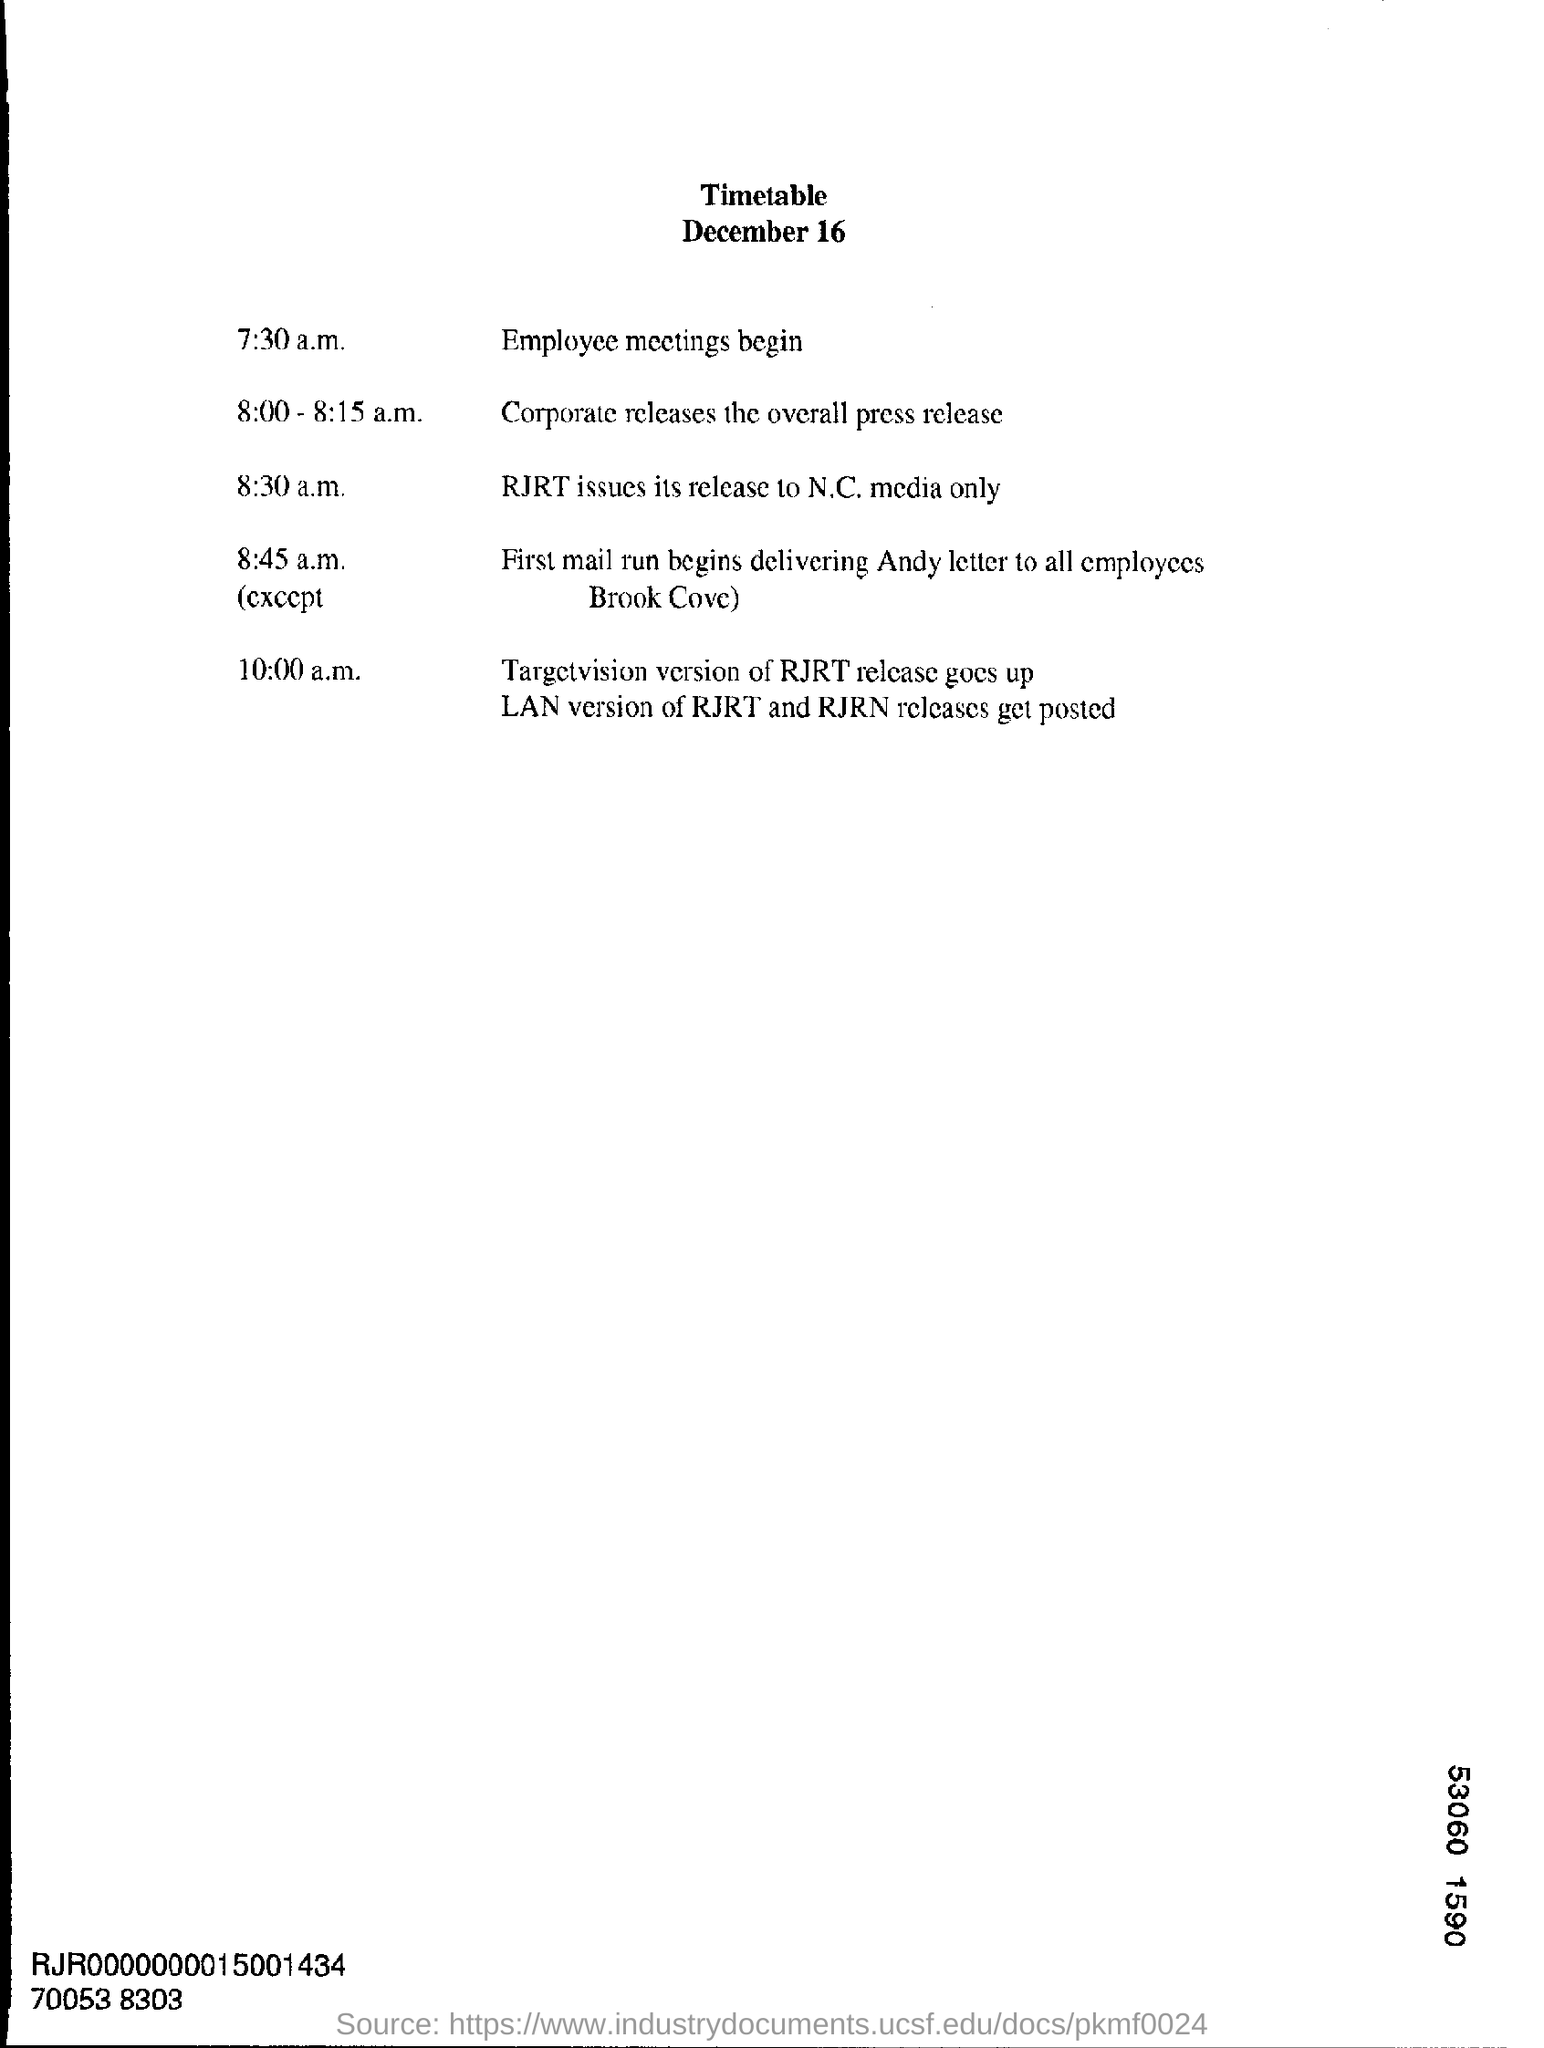Point out several critical features in this image. The heading of the document is 'Timetable'. The date mentioned is December 16. The Employee meeting is scheduled to begin at 7:30 a.m. 